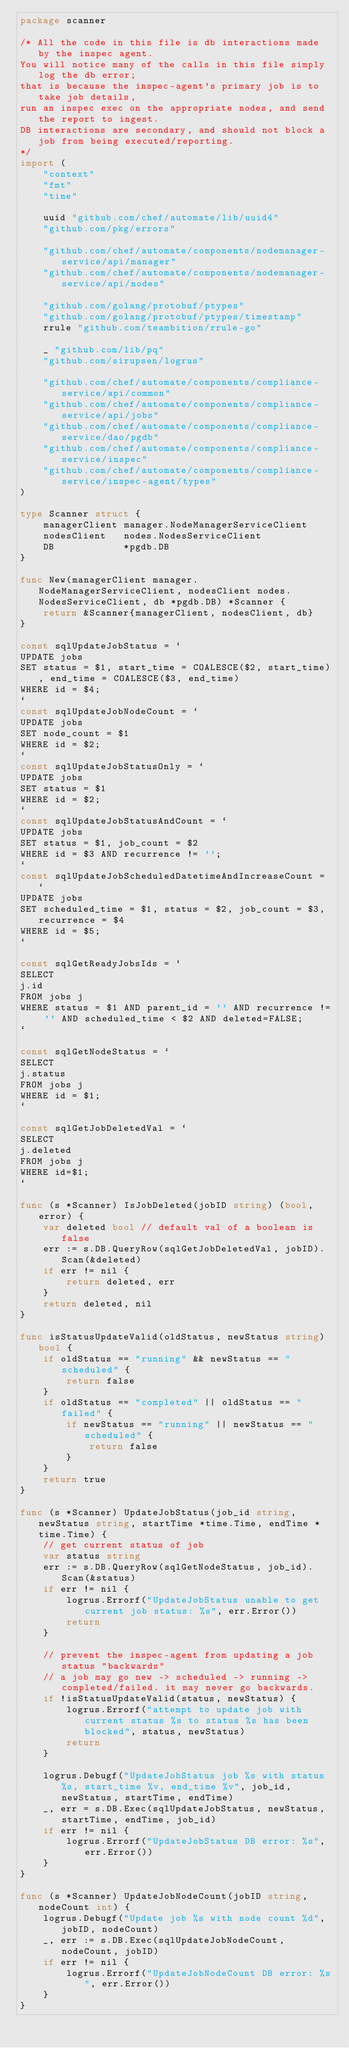Convert code to text. <code><loc_0><loc_0><loc_500><loc_500><_Go_>package scanner

/* All the code in this file is db interactions made by the inspec agent.
You will notice many of the calls in this file simply log the db error;
that is because the inspec-agent's primary job is to take job details,
run an inspec exec on the appropriate nodes, and send the report to ingest.
DB interactions are secondary, and should not block a job from being executed/reporting.
*/
import (
	"context"
	"fmt"
	"time"

	uuid "github.com/chef/automate/lib/uuid4"
	"github.com/pkg/errors"

	"github.com/chef/automate/components/nodemanager-service/api/manager"
	"github.com/chef/automate/components/nodemanager-service/api/nodes"

	"github.com/golang/protobuf/ptypes"
	"github.com/golang/protobuf/ptypes/timestamp"
	rrule "github.com/teambition/rrule-go"

	_ "github.com/lib/pq"
	"github.com/sirupsen/logrus"

	"github.com/chef/automate/components/compliance-service/api/common"
	"github.com/chef/automate/components/compliance-service/api/jobs"
	"github.com/chef/automate/components/compliance-service/dao/pgdb"
	"github.com/chef/automate/components/compliance-service/inspec"
	"github.com/chef/automate/components/compliance-service/inspec-agent/types"
)

type Scanner struct {
	managerClient manager.NodeManagerServiceClient
	nodesClient   nodes.NodesServiceClient
	DB            *pgdb.DB
}

func New(managerClient manager.NodeManagerServiceClient, nodesClient nodes.NodesServiceClient, db *pgdb.DB) *Scanner {
	return &Scanner{managerClient, nodesClient, db}
}

const sqlUpdateJobStatus = `
UPDATE jobs
SET status = $1, start_time = COALESCE($2, start_time), end_time = COALESCE($3, end_time)
WHERE id = $4;
`
const sqlUpdateJobNodeCount = `
UPDATE jobs
SET node_count = $1
WHERE id = $2;
`
const sqlUpdateJobStatusOnly = `
UPDATE jobs
SET status = $1
WHERE id = $2;
`
const sqlUpdateJobStatusAndCount = `
UPDATE jobs
SET status = $1, job_count = $2
WHERE id = $3 AND recurrence != '';
`
const sqlUpdateJobScheduledDatetimeAndIncreaseCount = `
UPDATE jobs
SET scheduled_time = $1, status = $2, job_count = $3, recurrence = $4
WHERE id = $5;
`

const sqlGetReadyJobsIds = `
SELECT
j.id
FROM jobs j
WHERE status = $1 AND parent_id = '' AND recurrence != '' AND scheduled_time < $2 AND deleted=FALSE;
`

const sqlGetNodeStatus = `
SELECT
j.status
FROM jobs j
WHERE id = $1;
`

const sqlGetJobDeletedVal = `
SELECT
j.deleted
FROM jobs j
WHERE id=$1;
`

func (s *Scanner) IsJobDeleted(jobID string) (bool, error) {
	var deleted bool // default val of a boolean is false
	err := s.DB.QueryRow(sqlGetJobDeletedVal, jobID).Scan(&deleted)
	if err != nil {
		return deleted, err
	}
	return deleted, nil
}

func isStatusUpdateValid(oldStatus, newStatus string) bool {
	if oldStatus == "running" && newStatus == "scheduled" {
		return false
	}
	if oldStatus == "completed" || oldStatus == "failed" {
		if newStatus == "running" || newStatus == "scheduled" {
			return false
		}
	}
	return true
}

func (s *Scanner) UpdateJobStatus(job_id string, newStatus string, startTime *time.Time, endTime *time.Time) {
	// get current status of job
	var status string
	err := s.DB.QueryRow(sqlGetNodeStatus, job_id).Scan(&status)
	if err != nil {
		logrus.Errorf("UpdateJobStatus unable to get current job status: %s", err.Error())
		return
	}

	// prevent the inspec-agent from updating a job status "backwards"
	// a job may go new -> scheduled -> running -> completed/failed. it may never go backwards.
	if !isStatusUpdateValid(status, newStatus) {
		logrus.Errorf("attempt to update job with current status %s to status %s has been blocked", status, newStatus)
		return
	}

	logrus.Debugf("UpdateJobStatus job %s with status %s, start_time %v, end_time %v", job_id, newStatus, startTime, endTime)
	_, err = s.DB.Exec(sqlUpdateJobStatus, newStatus, startTime, endTime, job_id)
	if err != nil {
		logrus.Errorf("UpdateJobStatus DB error: %s", err.Error())
	}
}

func (s *Scanner) UpdateJobNodeCount(jobID string, nodeCount int) {
	logrus.Debugf("Update job %s with node count %d", jobID, nodeCount)
	_, err := s.DB.Exec(sqlUpdateJobNodeCount, nodeCount, jobID)
	if err != nil {
		logrus.Errorf("UpdateJobNodeCount DB error: %s", err.Error())
	}
}
</code> 